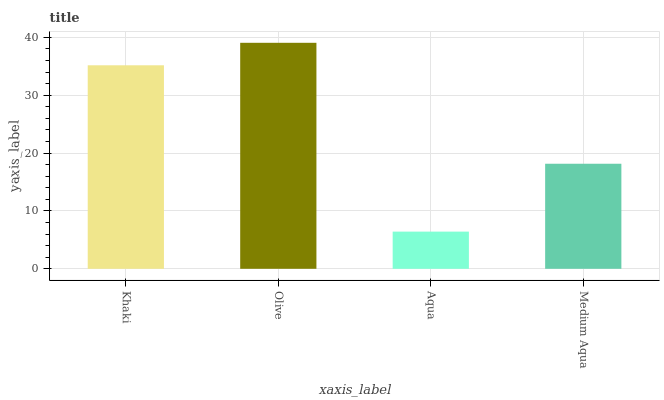Is Aqua the minimum?
Answer yes or no. Yes. Is Olive the maximum?
Answer yes or no. Yes. Is Olive the minimum?
Answer yes or no. No. Is Aqua the maximum?
Answer yes or no. No. Is Olive greater than Aqua?
Answer yes or no. Yes. Is Aqua less than Olive?
Answer yes or no. Yes. Is Aqua greater than Olive?
Answer yes or no. No. Is Olive less than Aqua?
Answer yes or no. No. Is Khaki the high median?
Answer yes or no. Yes. Is Medium Aqua the low median?
Answer yes or no. Yes. Is Medium Aqua the high median?
Answer yes or no. No. Is Olive the low median?
Answer yes or no. No. 